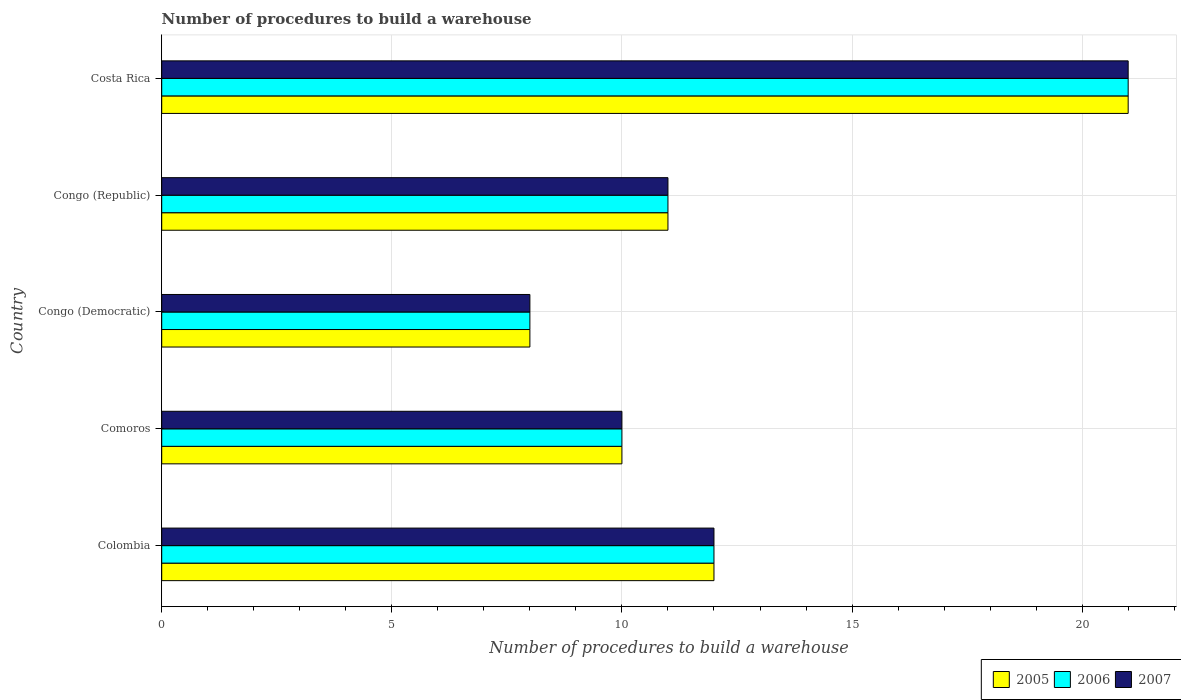How many different coloured bars are there?
Make the answer very short. 3. How many bars are there on the 3rd tick from the top?
Provide a succinct answer. 3. How many bars are there on the 4th tick from the bottom?
Your response must be concise. 3. What is the label of the 3rd group of bars from the top?
Give a very brief answer. Congo (Democratic). What is the number of procedures to build a warehouse in in 2005 in Colombia?
Keep it short and to the point. 12. Across all countries, what is the maximum number of procedures to build a warehouse in in 2006?
Offer a very short reply. 21. In which country was the number of procedures to build a warehouse in in 2006 maximum?
Provide a short and direct response. Costa Rica. In which country was the number of procedures to build a warehouse in in 2007 minimum?
Provide a succinct answer. Congo (Democratic). What is the total number of procedures to build a warehouse in in 2007 in the graph?
Offer a very short reply. 62. What is the difference between the number of procedures to build a warehouse in in 2007 in Colombia and that in Congo (Democratic)?
Keep it short and to the point. 4. What is the average number of procedures to build a warehouse in in 2006 per country?
Your answer should be compact. 12.4. What is the difference between the number of procedures to build a warehouse in in 2007 and number of procedures to build a warehouse in in 2006 in Colombia?
Keep it short and to the point. 0. What is the ratio of the number of procedures to build a warehouse in in 2007 in Colombia to that in Congo (Democratic)?
Offer a very short reply. 1.5. Is the difference between the number of procedures to build a warehouse in in 2007 in Comoros and Congo (Democratic) greater than the difference between the number of procedures to build a warehouse in in 2006 in Comoros and Congo (Democratic)?
Your response must be concise. No. What is the difference between the highest and the lowest number of procedures to build a warehouse in in 2005?
Your answer should be compact. 13. What does the 3rd bar from the top in Comoros represents?
Make the answer very short. 2005. What does the 2nd bar from the bottom in Congo (Democratic) represents?
Provide a short and direct response. 2006. How many countries are there in the graph?
Your answer should be very brief. 5. What is the difference between two consecutive major ticks on the X-axis?
Keep it short and to the point. 5. How many legend labels are there?
Provide a short and direct response. 3. What is the title of the graph?
Your response must be concise. Number of procedures to build a warehouse. What is the label or title of the X-axis?
Ensure brevity in your answer.  Number of procedures to build a warehouse. What is the label or title of the Y-axis?
Offer a very short reply. Country. What is the Number of procedures to build a warehouse in 2005 in Colombia?
Ensure brevity in your answer.  12. What is the Number of procedures to build a warehouse in 2006 in Colombia?
Make the answer very short. 12. What is the Number of procedures to build a warehouse in 2007 in Colombia?
Give a very brief answer. 12. What is the Number of procedures to build a warehouse in 2006 in Congo (Democratic)?
Keep it short and to the point. 8. What is the Number of procedures to build a warehouse of 2007 in Congo (Democratic)?
Give a very brief answer. 8. What is the Number of procedures to build a warehouse in 2005 in Congo (Republic)?
Make the answer very short. 11. What is the Number of procedures to build a warehouse of 2006 in Congo (Republic)?
Keep it short and to the point. 11. What is the Number of procedures to build a warehouse of 2007 in Congo (Republic)?
Ensure brevity in your answer.  11. What is the Number of procedures to build a warehouse of 2005 in Costa Rica?
Offer a terse response. 21. What is the Number of procedures to build a warehouse in 2006 in Costa Rica?
Your answer should be compact. 21. What is the Number of procedures to build a warehouse in 2007 in Costa Rica?
Make the answer very short. 21. Across all countries, what is the maximum Number of procedures to build a warehouse of 2005?
Give a very brief answer. 21. Across all countries, what is the minimum Number of procedures to build a warehouse of 2005?
Your answer should be very brief. 8. Across all countries, what is the minimum Number of procedures to build a warehouse in 2006?
Offer a terse response. 8. What is the total Number of procedures to build a warehouse of 2007 in the graph?
Give a very brief answer. 62. What is the difference between the Number of procedures to build a warehouse of 2006 in Colombia and that in Comoros?
Your answer should be very brief. 2. What is the difference between the Number of procedures to build a warehouse of 2007 in Colombia and that in Comoros?
Your answer should be very brief. 2. What is the difference between the Number of procedures to build a warehouse of 2005 in Colombia and that in Congo (Democratic)?
Provide a short and direct response. 4. What is the difference between the Number of procedures to build a warehouse of 2007 in Colombia and that in Congo (Democratic)?
Your response must be concise. 4. What is the difference between the Number of procedures to build a warehouse in 2005 in Colombia and that in Congo (Republic)?
Your answer should be compact. 1. What is the difference between the Number of procedures to build a warehouse of 2007 in Colombia and that in Congo (Republic)?
Ensure brevity in your answer.  1. What is the difference between the Number of procedures to build a warehouse in 2005 in Colombia and that in Costa Rica?
Offer a terse response. -9. What is the difference between the Number of procedures to build a warehouse of 2007 in Colombia and that in Costa Rica?
Ensure brevity in your answer.  -9. What is the difference between the Number of procedures to build a warehouse in 2005 in Comoros and that in Congo (Republic)?
Your answer should be very brief. -1. What is the difference between the Number of procedures to build a warehouse in 2006 in Comoros and that in Congo (Republic)?
Give a very brief answer. -1. What is the difference between the Number of procedures to build a warehouse in 2007 in Comoros and that in Congo (Republic)?
Provide a short and direct response. -1. What is the difference between the Number of procedures to build a warehouse of 2006 in Comoros and that in Costa Rica?
Your answer should be very brief. -11. What is the difference between the Number of procedures to build a warehouse of 2005 in Congo (Democratic) and that in Congo (Republic)?
Ensure brevity in your answer.  -3. What is the difference between the Number of procedures to build a warehouse in 2005 in Congo (Democratic) and that in Costa Rica?
Provide a short and direct response. -13. What is the difference between the Number of procedures to build a warehouse in 2006 in Congo (Republic) and that in Costa Rica?
Offer a very short reply. -10. What is the difference between the Number of procedures to build a warehouse in 2007 in Congo (Republic) and that in Costa Rica?
Provide a short and direct response. -10. What is the difference between the Number of procedures to build a warehouse of 2005 in Colombia and the Number of procedures to build a warehouse of 2006 in Comoros?
Give a very brief answer. 2. What is the difference between the Number of procedures to build a warehouse in 2005 in Colombia and the Number of procedures to build a warehouse in 2007 in Comoros?
Offer a terse response. 2. What is the difference between the Number of procedures to build a warehouse in 2005 in Colombia and the Number of procedures to build a warehouse in 2006 in Congo (Republic)?
Offer a very short reply. 1. What is the difference between the Number of procedures to build a warehouse of 2006 in Colombia and the Number of procedures to build a warehouse of 2007 in Congo (Republic)?
Offer a very short reply. 1. What is the difference between the Number of procedures to build a warehouse of 2005 in Colombia and the Number of procedures to build a warehouse of 2007 in Costa Rica?
Keep it short and to the point. -9. What is the difference between the Number of procedures to build a warehouse of 2006 in Colombia and the Number of procedures to build a warehouse of 2007 in Costa Rica?
Offer a terse response. -9. What is the difference between the Number of procedures to build a warehouse of 2005 in Comoros and the Number of procedures to build a warehouse of 2006 in Congo (Democratic)?
Keep it short and to the point. 2. What is the difference between the Number of procedures to build a warehouse of 2006 in Comoros and the Number of procedures to build a warehouse of 2007 in Congo (Democratic)?
Make the answer very short. 2. What is the difference between the Number of procedures to build a warehouse in 2005 in Comoros and the Number of procedures to build a warehouse in 2006 in Congo (Republic)?
Provide a succinct answer. -1. What is the difference between the Number of procedures to build a warehouse of 2005 in Comoros and the Number of procedures to build a warehouse of 2007 in Congo (Republic)?
Give a very brief answer. -1. What is the difference between the Number of procedures to build a warehouse of 2006 in Comoros and the Number of procedures to build a warehouse of 2007 in Costa Rica?
Make the answer very short. -11. What is the difference between the Number of procedures to build a warehouse in 2005 in Congo (Democratic) and the Number of procedures to build a warehouse in 2006 in Congo (Republic)?
Keep it short and to the point. -3. What is the difference between the Number of procedures to build a warehouse in 2006 in Congo (Democratic) and the Number of procedures to build a warehouse in 2007 in Congo (Republic)?
Offer a very short reply. -3. What is the difference between the Number of procedures to build a warehouse in 2005 in Congo (Democratic) and the Number of procedures to build a warehouse in 2006 in Costa Rica?
Offer a terse response. -13. What is the difference between the Number of procedures to build a warehouse in 2006 in Congo (Democratic) and the Number of procedures to build a warehouse in 2007 in Costa Rica?
Provide a succinct answer. -13. What is the difference between the Number of procedures to build a warehouse of 2005 in Congo (Republic) and the Number of procedures to build a warehouse of 2006 in Costa Rica?
Your answer should be compact. -10. What is the difference between the Number of procedures to build a warehouse of 2006 in Congo (Republic) and the Number of procedures to build a warehouse of 2007 in Costa Rica?
Keep it short and to the point. -10. What is the average Number of procedures to build a warehouse of 2005 per country?
Provide a short and direct response. 12.4. What is the average Number of procedures to build a warehouse of 2007 per country?
Provide a succinct answer. 12.4. What is the difference between the Number of procedures to build a warehouse of 2005 and Number of procedures to build a warehouse of 2006 in Colombia?
Make the answer very short. 0. What is the difference between the Number of procedures to build a warehouse in 2005 and Number of procedures to build a warehouse in 2007 in Colombia?
Your answer should be compact. 0. What is the difference between the Number of procedures to build a warehouse in 2006 and Number of procedures to build a warehouse in 2007 in Colombia?
Make the answer very short. 0. What is the difference between the Number of procedures to build a warehouse of 2005 and Number of procedures to build a warehouse of 2006 in Congo (Democratic)?
Ensure brevity in your answer.  0. What is the difference between the Number of procedures to build a warehouse in 2005 and Number of procedures to build a warehouse in 2007 in Congo (Democratic)?
Keep it short and to the point. 0. What is the difference between the Number of procedures to build a warehouse in 2006 and Number of procedures to build a warehouse in 2007 in Congo (Democratic)?
Provide a short and direct response. 0. What is the difference between the Number of procedures to build a warehouse in 2005 and Number of procedures to build a warehouse in 2006 in Congo (Republic)?
Make the answer very short. 0. What is the difference between the Number of procedures to build a warehouse in 2005 and Number of procedures to build a warehouse in 2007 in Congo (Republic)?
Provide a short and direct response. 0. What is the difference between the Number of procedures to build a warehouse of 2006 and Number of procedures to build a warehouse of 2007 in Congo (Republic)?
Ensure brevity in your answer.  0. What is the difference between the Number of procedures to build a warehouse of 2006 and Number of procedures to build a warehouse of 2007 in Costa Rica?
Ensure brevity in your answer.  0. What is the ratio of the Number of procedures to build a warehouse in 2005 in Colombia to that in Congo (Democratic)?
Keep it short and to the point. 1.5. What is the ratio of the Number of procedures to build a warehouse of 2007 in Colombia to that in Congo (Democratic)?
Make the answer very short. 1.5. What is the ratio of the Number of procedures to build a warehouse in 2005 in Colombia to that in Costa Rica?
Make the answer very short. 0.57. What is the ratio of the Number of procedures to build a warehouse of 2005 in Comoros to that in Congo (Democratic)?
Offer a very short reply. 1.25. What is the ratio of the Number of procedures to build a warehouse in 2006 in Comoros to that in Congo (Democratic)?
Your response must be concise. 1.25. What is the ratio of the Number of procedures to build a warehouse of 2005 in Comoros to that in Congo (Republic)?
Provide a succinct answer. 0.91. What is the ratio of the Number of procedures to build a warehouse in 2005 in Comoros to that in Costa Rica?
Ensure brevity in your answer.  0.48. What is the ratio of the Number of procedures to build a warehouse in 2006 in Comoros to that in Costa Rica?
Provide a short and direct response. 0.48. What is the ratio of the Number of procedures to build a warehouse in 2007 in Comoros to that in Costa Rica?
Your answer should be very brief. 0.48. What is the ratio of the Number of procedures to build a warehouse in 2005 in Congo (Democratic) to that in Congo (Republic)?
Provide a short and direct response. 0.73. What is the ratio of the Number of procedures to build a warehouse of 2006 in Congo (Democratic) to that in Congo (Republic)?
Your response must be concise. 0.73. What is the ratio of the Number of procedures to build a warehouse in 2007 in Congo (Democratic) to that in Congo (Republic)?
Give a very brief answer. 0.73. What is the ratio of the Number of procedures to build a warehouse of 2005 in Congo (Democratic) to that in Costa Rica?
Your answer should be compact. 0.38. What is the ratio of the Number of procedures to build a warehouse in 2006 in Congo (Democratic) to that in Costa Rica?
Your answer should be very brief. 0.38. What is the ratio of the Number of procedures to build a warehouse of 2007 in Congo (Democratic) to that in Costa Rica?
Offer a very short reply. 0.38. What is the ratio of the Number of procedures to build a warehouse in 2005 in Congo (Republic) to that in Costa Rica?
Your answer should be very brief. 0.52. What is the ratio of the Number of procedures to build a warehouse in 2006 in Congo (Republic) to that in Costa Rica?
Ensure brevity in your answer.  0.52. What is the ratio of the Number of procedures to build a warehouse of 2007 in Congo (Republic) to that in Costa Rica?
Provide a succinct answer. 0.52. What is the difference between the highest and the second highest Number of procedures to build a warehouse of 2005?
Offer a very short reply. 9. What is the difference between the highest and the second highest Number of procedures to build a warehouse of 2006?
Provide a short and direct response. 9. What is the difference between the highest and the second highest Number of procedures to build a warehouse in 2007?
Make the answer very short. 9. 